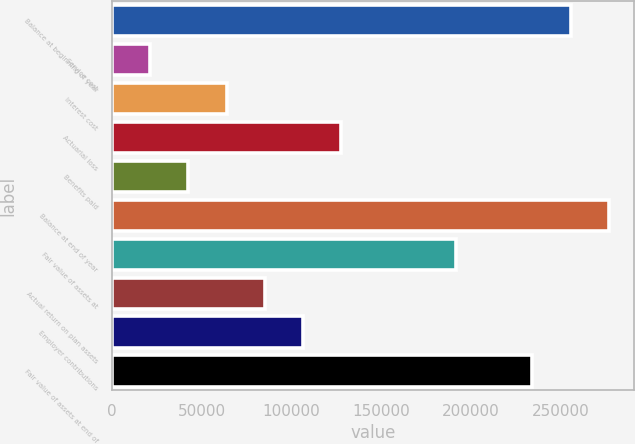<chart> <loc_0><loc_0><loc_500><loc_500><bar_chart><fcel>Balance at beginning of year<fcel>Service cost<fcel>Interest cost<fcel>Actuarial loss<fcel>Benefits paid<fcel>Balance at end of year<fcel>Fair value of assets at<fcel>Actual return on plan assets<fcel>Employer contributions<fcel>Fair value of assets at end of<nl><fcel>255711<fcel>21341.3<fcel>63953.9<fcel>127873<fcel>42647.6<fcel>277017<fcel>191792<fcel>85260.2<fcel>106566<fcel>234404<nl></chart> 